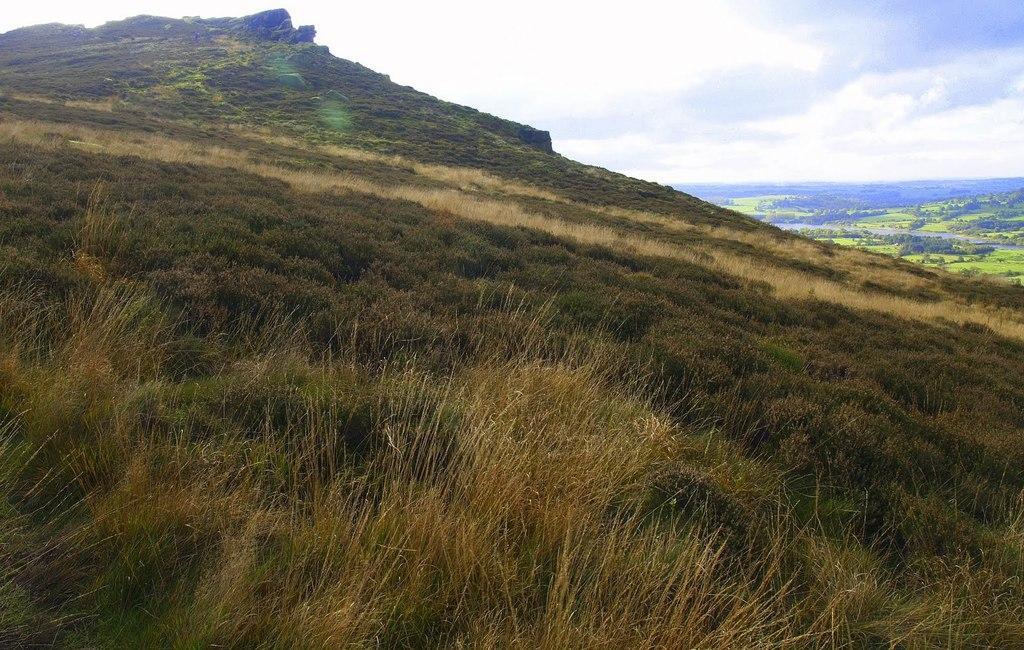In one or two sentences, can you explain what this image depicts? There is grassland in the foreground area of the image, it seems like mountains and the sky in the background. 